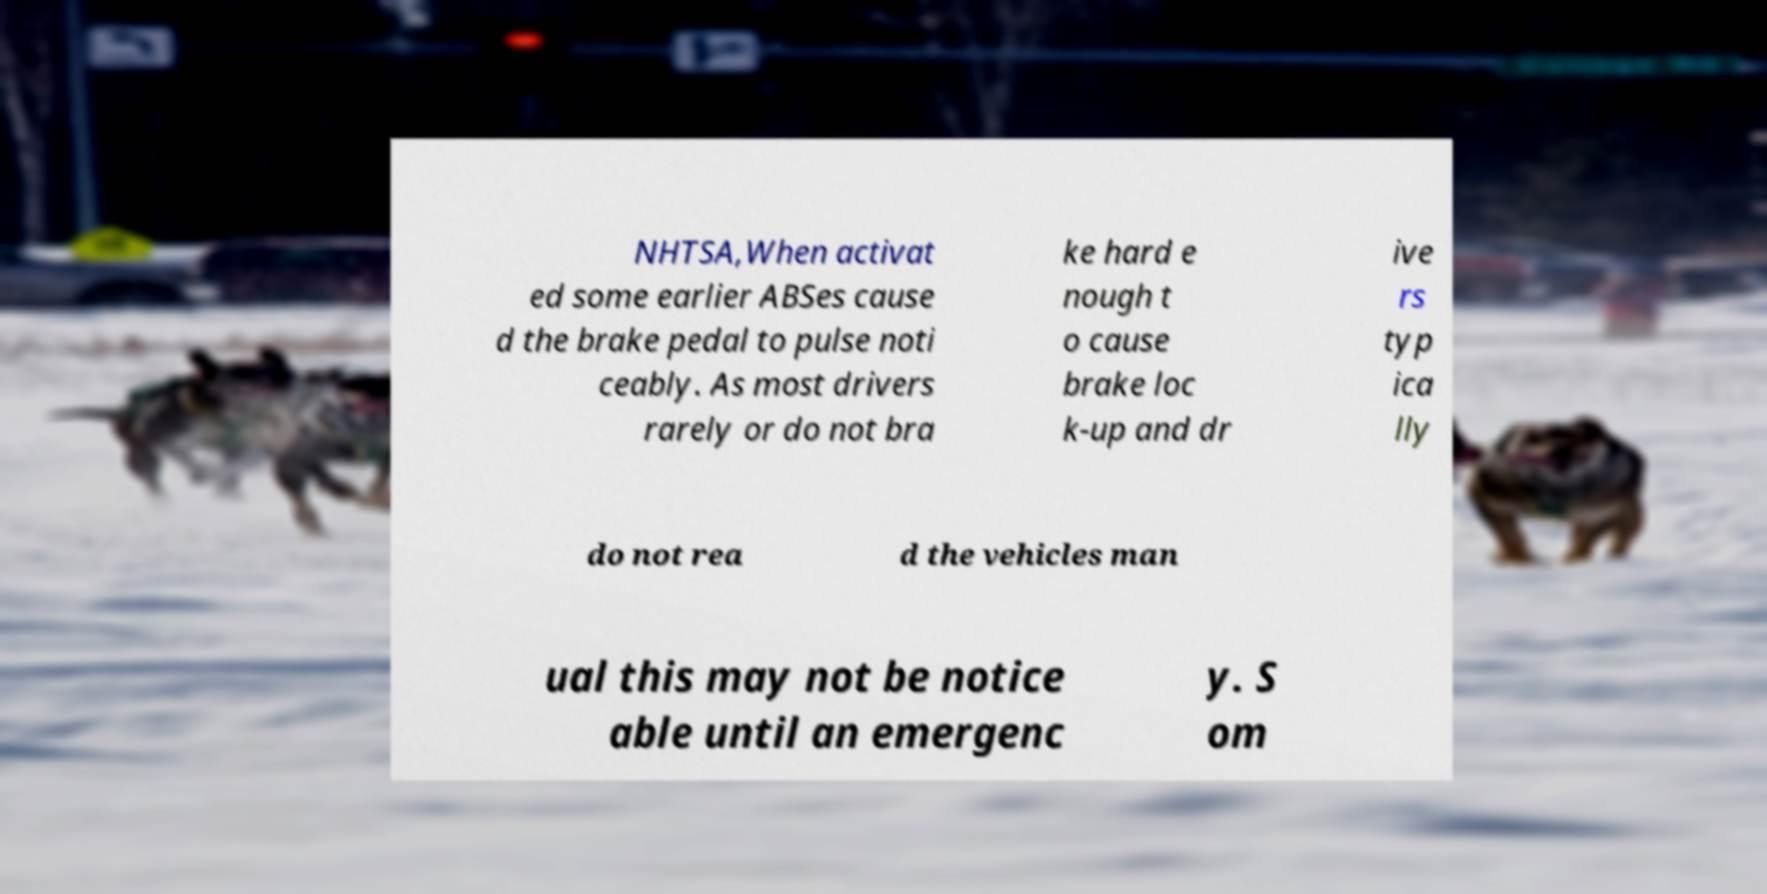I need the written content from this picture converted into text. Can you do that? NHTSA,When activat ed some earlier ABSes cause d the brake pedal to pulse noti ceably. As most drivers rarely or do not bra ke hard e nough t o cause brake loc k-up and dr ive rs typ ica lly do not rea d the vehicles man ual this may not be notice able until an emergenc y. S om 